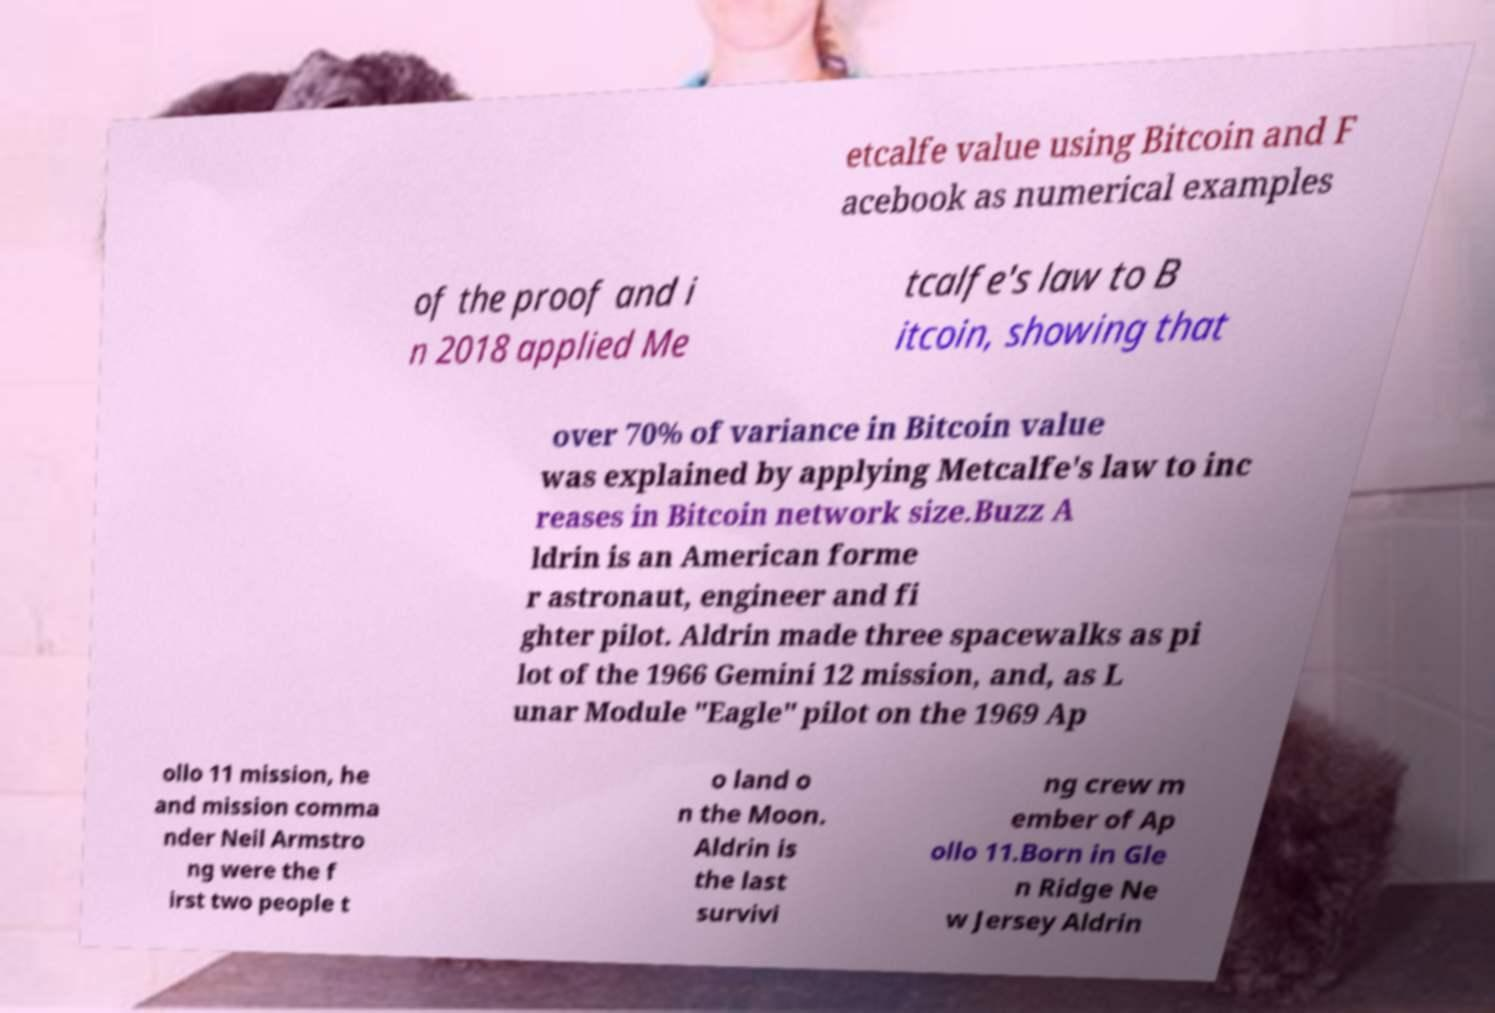Could you extract and type out the text from this image? etcalfe value using Bitcoin and F acebook as numerical examples of the proof and i n 2018 applied Me tcalfe's law to B itcoin, showing that over 70% of variance in Bitcoin value was explained by applying Metcalfe's law to inc reases in Bitcoin network size.Buzz A ldrin is an American forme r astronaut, engineer and fi ghter pilot. Aldrin made three spacewalks as pi lot of the 1966 Gemini 12 mission, and, as L unar Module "Eagle" pilot on the 1969 Ap ollo 11 mission, he and mission comma nder Neil Armstro ng were the f irst two people t o land o n the Moon. Aldrin is the last survivi ng crew m ember of Ap ollo 11.Born in Gle n Ridge Ne w Jersey Aldrin 